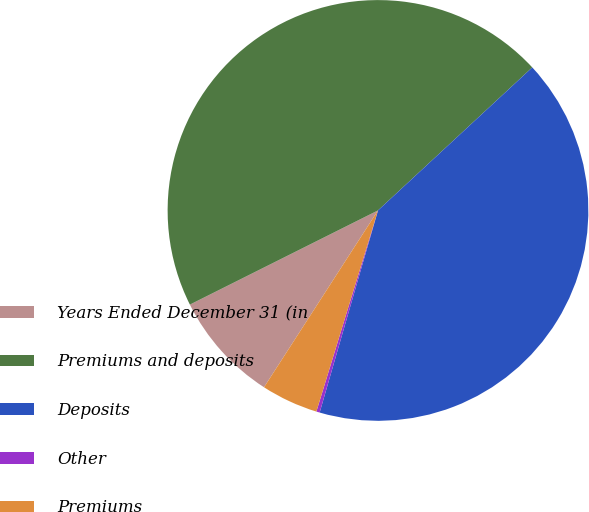<chart> <loc_0><loc_0><loc_500><loc_500><pie_chart><fcel>Years Ended December 31 (in<fcel>Premiums and deposits<fcel>Deposits<fcel>Other<fcel>Premiums<nl><fcel>8.5%<fcel>45.49%<fcel>41.37%<fcel>0.26%<fcel>4.38%<nl></chart> 